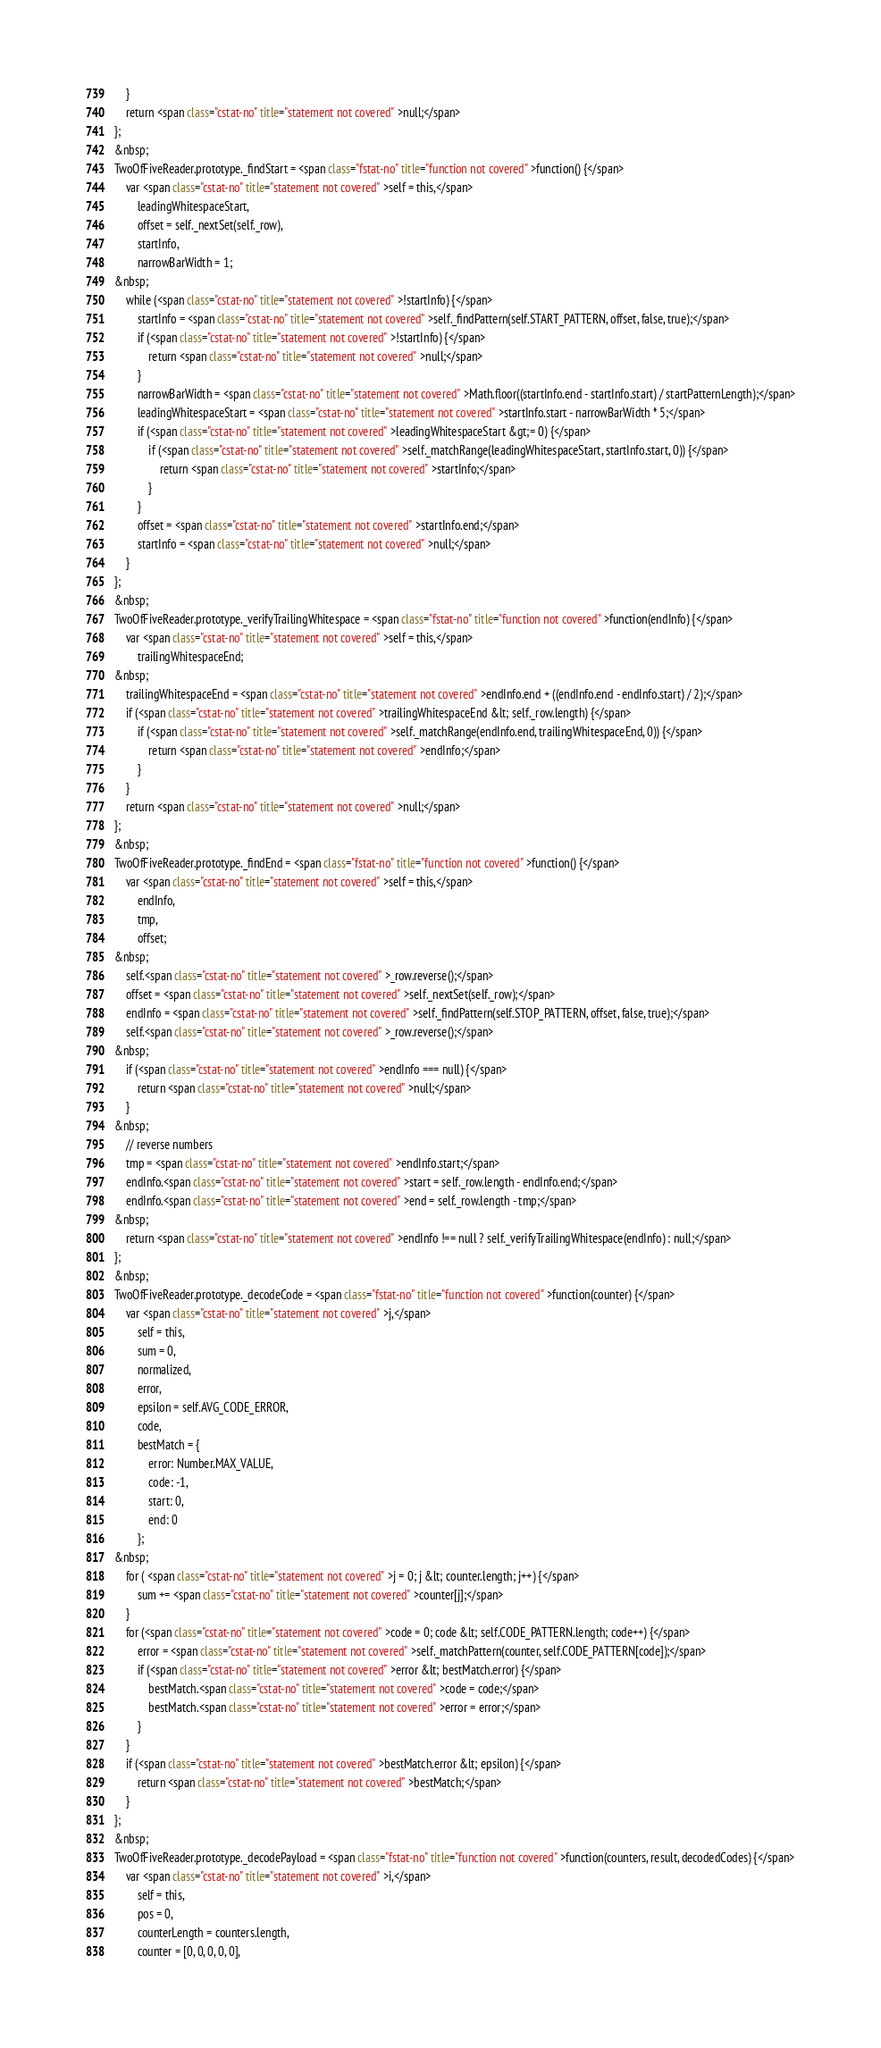Convert code to text. <code><loc_0><loc_0><loc_500><loc_500><_HTML_>    }
    return <span class="cstat-no" title="statement not covered" >null;</span>
};
&nbsp;
TwoOfFiveReader.prototype._findStart = <span class="fstat-no" title="function not covered" >function() {</span>
    var <span class="cstat-no" title="statement not covered" >self = this,</span>
        leadingWhitespaceStart,
        offset = self._nextSet(self._row),
        startInfo,
        narrowBarWidth = 1;
&nbsp;
    while (<span class="cstat-no" title="statement not covered" >!startInfo) {</span>
        startInfo = <span class="cstat-no" title="statement not covered" >self._findPattern(self.START_PATTERN, offset, false, true);</span>
        if (<span class="cstat-no" title="statement not covered" >!startInfo) {</span>
            return <span class="cstat-no" title="statement not covered" >null;</span>
        }
        narrowBarWidth = <span class="cstat-no" title="statement not covered" >Math.floor((startInfo.end - startInfo.start) / startPatternLength);</span>
        leadingWhitespaceStart = <span class="cstat-no" title="statement not covered" >startInfo.start - narrowBarWidth * 5;</span>
        if (<span class="cstat-no" title="statement not covered" >leadingWhitespaceStart &gt;= 0) {</span>
            if (<span class="cstat-no" title="statement not covered" >self._matchRange(leadingWhitespaceStart, startInfo.start, 0)) {</span>
                return <span class="cstat-no" title="statement not covered" >startInfo;</span>
            }
        }
        offset = <span class="cstat-no" title="statement not covered" >startInfo.end;</span>
        startInfo = <span class="cstat-no" title="statement not covered" >null;</span>
    }
};
&nbsp;
TwoOfFiveReader.prototype._verifyTrailingWhitespace = <span class="fstat-no" title="function not covered" >function(endInfo) {</span>
    var <span class="cstat-no" title="statement not covered" >self = this,</span>
        trailingWhitespaceEnd;
&nbsp;
    trailingWhitespaceEnd = <span class="cstat-no" title="statement not covered" >endInfo.end + ((endInfo.end - endInfo.start) / 2);</span>
    if (<span class="cstat-no" title="statement not covered" >trailingWhitespaceEnd &lt; self._row.length) {</span>
        if (<span class="cstat-no" title="statement not covered" >self._matchRange(endInfo.end, trailingWhitespaceEnd, 0)) {</span>
            return <span class="cstat-no" title="statement not covered" >endInfo;</span>
        }
    }
    return <span class="cstat-no" title="statement not covered" >null;</span>
};
&nbsp;
TwoOfFiveReader.prototype._findEnd = <span class="fstat-no" title="function not covered" >function() {</span>
    var <span class="cstat-no" title="statement not covered" >self = this,</span>
        endInfo,
        tmp,
        offset;
&nbsp;
    self.<span class="cstat-no" title="statement not covered" >_row.reverse();</span>
    offset = <span class="cstat-no" title="statement not covered" >self._nextSet(self._row);</span>
    endInfo = <span class="cstat-no" title="statement not covered" >self._findPattern(self.STOP_PATTERN, offset, false, true);</span>
    self.<span class="cstat-no" title="statement not covered" >_row.reverse();</span>
&nbsp;
    if (<span class="cstat-no" title="statement not covered" >endInfo === null) {</span>
        return <span class="cstat-no" title="statement not covered" >null;</span>
    }
&nbsp;
    // reverse numbers
    tmp = <span class="cstat-no" title="statement not covered" >endInfo.start;</span>
    endInfo.<span class="cstat-no" title="statement not covered" >start = self._row.length - endInfo.end;</span>
    endInfo.<span class="cstat-no" title="statement not covered" >end = self._row.length - tmp;</span>
&nbsp;
    return <span class="cstat-no" title="statement not covered" >endInfo !== null ? self._verifyTrailingWhitespace(endInfo) : null;</span>
};
&nbsp;
TwoOfFiveReader.prototype._decodeCode = <span class="fstat-no" title="function not covered" >function(counter) {</span>
    var <span class="cstat-no" title="statement not covered" >j,</span>
        self = this,
        sum = 0,
        normalized,
        error,
        epsilon = self.AVG_CODE_ERROR,
        code,
        bestMatch = {
            error: Number.MAX_VALUE,
            code: -1,
            start: 0,
            end: 0
        };
&nbsp;
    for ( <span class="cstat-no" title="statement not covered" >j = 0; j &lt; counter.length; j++) {</span>
        sum += <span class="cstat-no" title="statement not covered" >counter[j];</span>
    }
    for (<span class="cstat-no" title="statement not covered" >code = 0; code &lt; self.CODE_PATTERN.length; code++) {</span>
        error = <span class="cstat-no" title="statement not covered" >self._matchPattern(counter, self.CODE_PATTERN[code]);</span>
        if (<span class="cstat-no" title="statement not covered" >error &lt; bestMatch.error) {</span>
            bestMatch.<span class="cstat-no" title="statement not covered" >code = code;</span>
            bestMatch.<span class="cstat-no" title="statement not covered" >error = error;</span>
        }
    }
    if (<span class="cstat-no" title="statement not covered" >bestMatch.error &lt; epsilon) {</span>
        return <span class="cstat-no" title="statement not covered" >bestMatch;</span>
    }
};
&nbsp;
TwoOfFiveReader.prototype._decodePayload = <span class="fstat-no" title="function not covered" >function(counters, result, decodedCodes) {</span>
    var <span class="cstat-no" title="statement not covered" >i,</span>
        self = this,
        pos = 0,
        counterLength = counters.length,
        counter = [0, 0, 0, 0, 0],</code> 